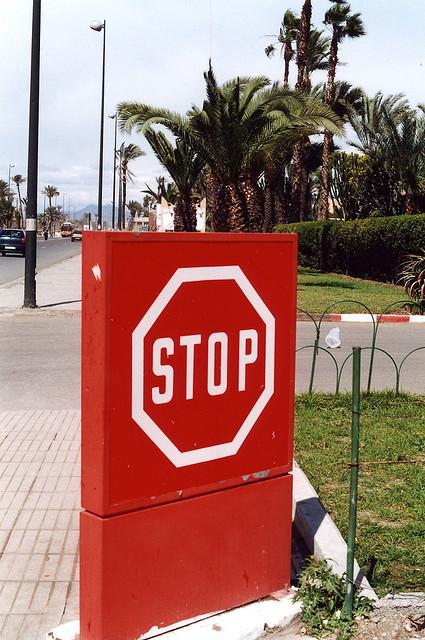What type of traffic sign?
Short answer required. Stop. Are there any palm trees by the sidewalk?
Be succinct. Yes. What shape is the stop sign?
Give a very brief answer. Octagon. Is this a big street?
Quick response, please. Yes. 